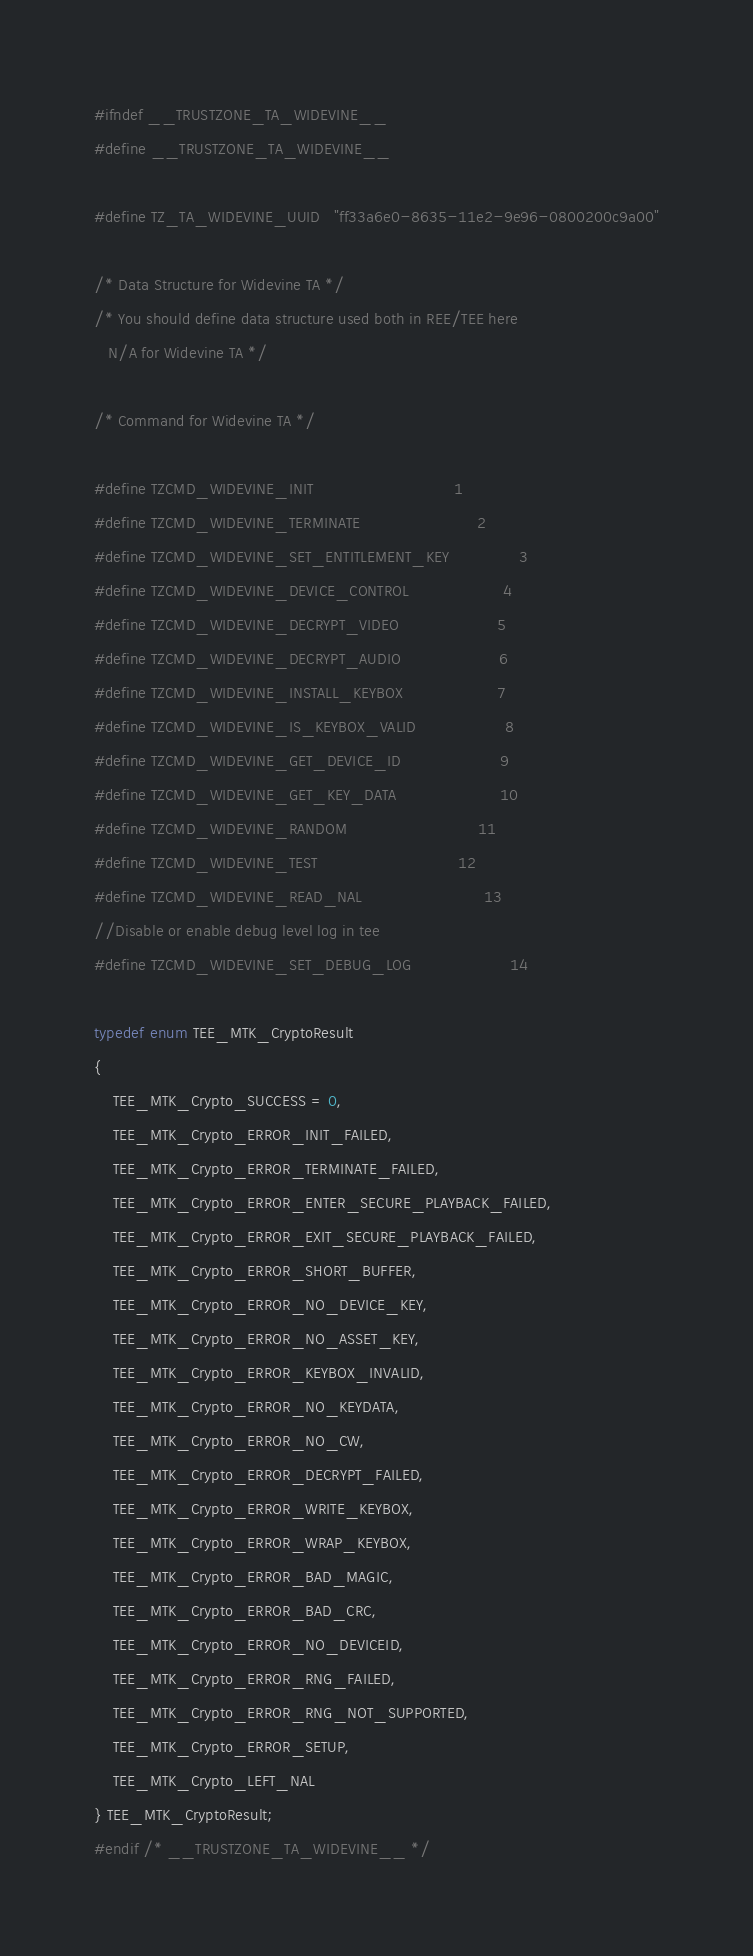<code> <loc_0><loc_0><loc_500><loc_500><_C_>#ifndef __TRUSTZONE_TA_WIDEVINE__
#define __TRUSTZONE_TA_WIDEVINE__

#define TZ_TA_WIDEVINE_UUID   "ff33a6e0-8635-11e2-9e96-0800200c9a00"

/* Data Structure for Widevine TA */
/* You should define data structure used both in REE/TEE here
   N/A for Widevine TA */

/* Command for Widevine TA */

#define TZCMD_WIDEVINE_INIT                              1
#define TZCMD_WIDEVINE_TERMINATE                         2
#define TZCMD_WIDEVINE_SET_ENTITLEMENT_KEY               3
#define TZCMD_WIDEVINE_DEVICE_CONTROL                    4
#define TZCMD_WIDEVINE_DECRYPT_VIDEO                     5
#define TZCMD_WIDEVINE_DECRYPT_AUDIO                     6
#define TZCMD_WIDEVINE_INSTALL_KEYBOX                    7
#define TZCMD_WIDEVINE_IS_KEYBOX_VALID                   8
#define TZCMD_WIDEVINE_GET_DEVICE_ID                     9
#define TZCMD_WIDEVINE_GET_KEY_DATA                      10
#define TZCMD_WIDEVINE_RANDOM                            11
#define TZCMD_WIDEVINE_TEST                              12
#define TZCMD_WIDEVINE_READ_NAL                          13
//Disable or enable debug level log in tee
#define TZCMD_WIDEVINE_SET_DEBUG_LOG                     14

typedef enum TEE_MTK_CryptoResult
{
    TEE_MTK_Crypto_SUCCESS = 0,
    TEE_MTK_Crypto_ERROR_INIT_FAILED,
    TEE_MTK_Crypto_ERROR_TERMINATE_FAILED,
    TEE_MTK_Crypto_ERROR_ENTER_SECURE_PLAYBACK_FAILED,
    TEE_MTK_Crypto_ERROR_EXIT_SECURE_PLAYBACK_FAILED,
    TEE_MTK_Crypto_ERROR_SHORT_BUFFER,
    TEE_MTK_Crypto_ERROR_NO_DEVICE_KEY,
    TEE_MTK_Crypto_ERROR_NO_ASSET_KEY,
    TEE_MTK_Crypto_ERROR_KEYBOX_INVALID,
    TEE_MTK_Crypto_ERROR_NO_KEYDATA,
    TEE_MTK_Crypto_ERROR_NO_CW,
    TEE_MTK_Crypto_ERROR_DECRYPT_FAILED,
    TEE_MTK_Crypto_ERROR_WRITE_KEYBOX,
    TEE_MTK_Crypto_ERROR_WRAP_KEYBOX,
    TEE_MTK_Crypto_ERROR_BAD_MAGIC,
    TEE_MTK_Crypto_ERROR_BAD_CRC,
    TEE_MTK_Crypto_ERROR_NO_DEVICEID,
    TEE_MTK_Crypto_ERROR_RNG_FAILED,
    TEE_MTK_Crypto_ERROR_RNG_NOT_SUPPORTED,
    TEE_MTK_Crypto_ERROR_SETUP,
    TEE_MTK_Crypto_LEFT_NAL
} TEE_MTK_CryptoResult;
#endif /* __TRUSTZONE_TA_WIDEVINE__ */
</code> 